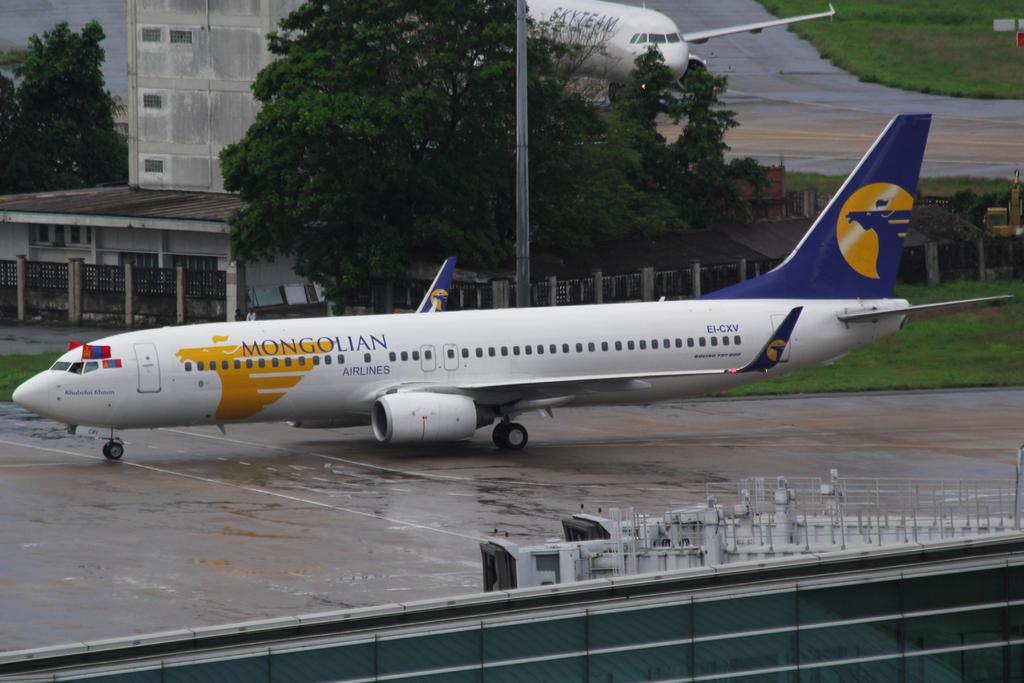Provide a one-sentence caption for the provided image. A Mongolian airplane is on a wet runway. 